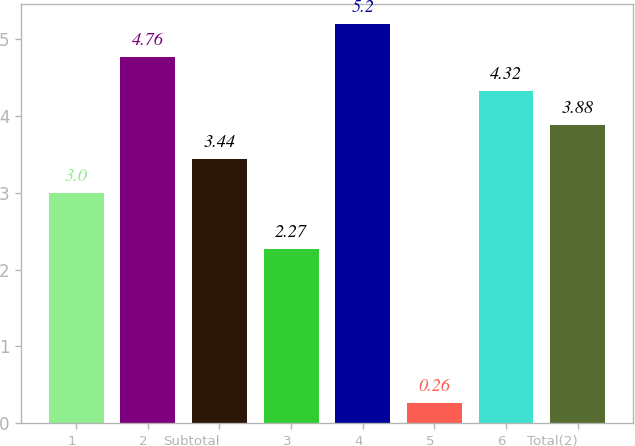<chart> <loc_0><loc_0><loc_500><loc_500><bar_chart><fcel>1<fcel>2<fcel>Subtotal<fcel>3<fcel>4<fcel>5<fcel>6<fcel>Total(2)<nl><fcel>3<fcel>4.76<fcel>3.44<fcel>2.27<fcel>5.2<fcel>0.26<fcel>4.32<fcel>3.88<nl></chart> 